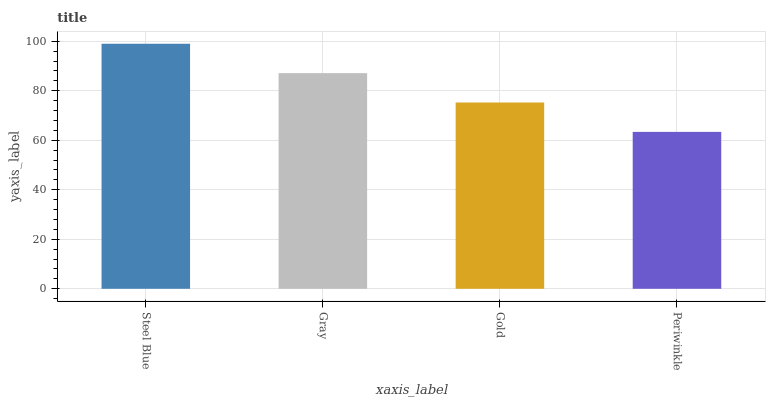Is Periwinkle the minimum?
Answer yes or no. Yes. Is Steel Blue the maximum?
Answer yes or no. Yes. Is Gray the minimum?
Answer yes or no. No. Is Gray the maximum?
Answer yes or no. No. Is Steel Blue greater than Gray?
Answer yes or no. Yes. Is Gray less than Steel Blue?
Answer yes or no. Yes. Is Gray greater than Steel Blue?
Answer yes or no. No. Is Steel Blue less than Gray?
Answer yes or no. No. Is Gray the high median?
Answer yes or no. Yes. Is Gold the low median?
Answer yes or no. Yes. Is Steel Blue the high median?
Answer yes or no. No. Is Periwinkle the low median?
Answer yes or no. No. 